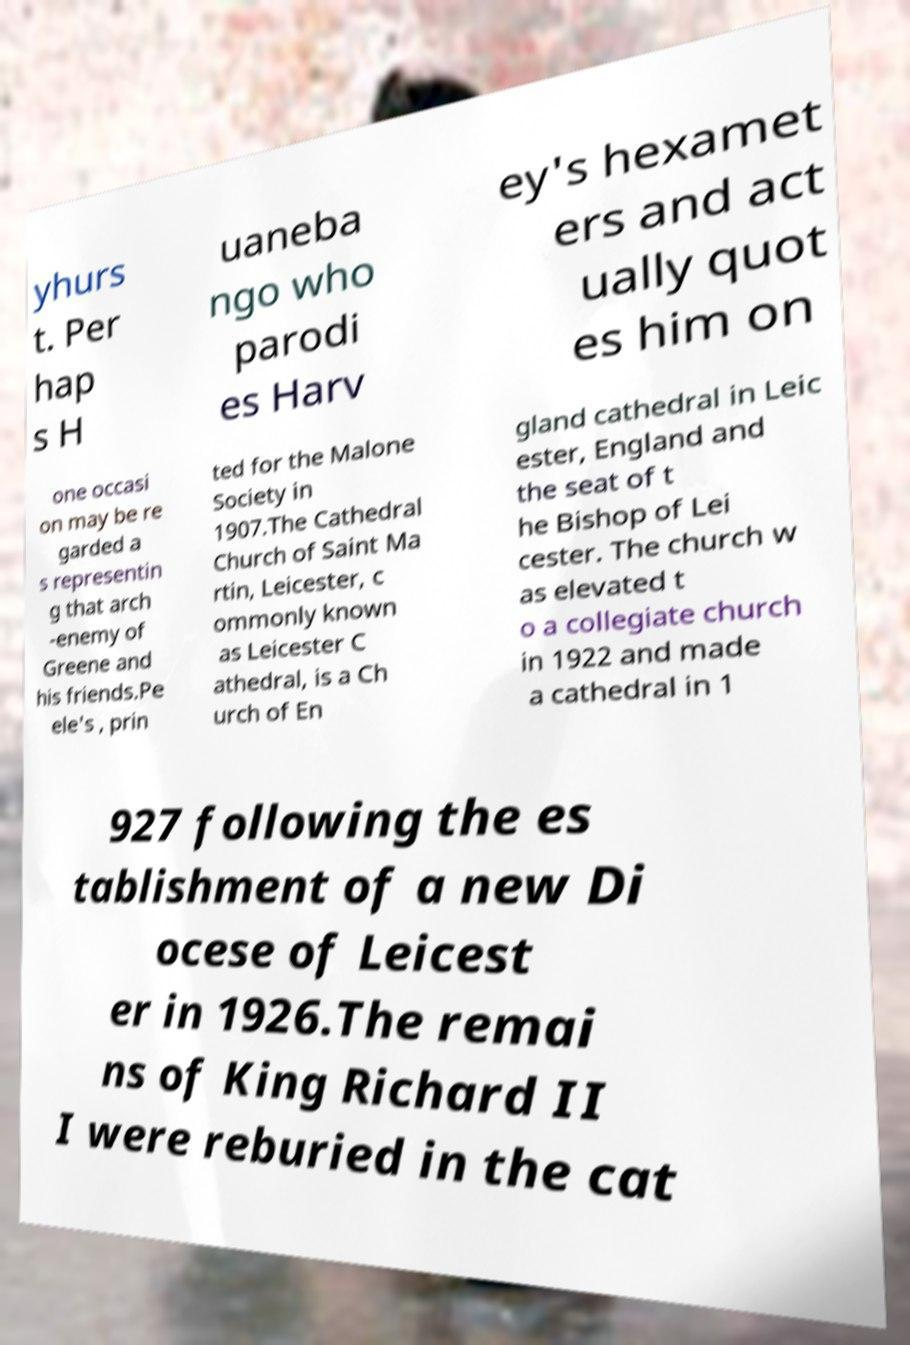I need the written content from this picture converted into text. Can you do that? yhurs t. Per hap s H uaneba ngo who parodi es Harv ey's hexamet ers and act ually quot es him on one occasi on may be re garded a s representin g that arch -enemy of Greene and his friends.Pe ele's , prin ted for the Malone Society in 1907.The Cathedral Church of Saint Ma rtin, Leicester, c ommonly known as Leicester C athedral, is a Ch urch of En gland cathedral in Leic ester, England and the seat of t he Bishop of Lei cester. The church w as elevated t o a collegiate church in 1922 and made a cathedral in 1 927 following the es tablishment of a new Di ocese of Leicest er in 1926.The remai ns of King Richard II I were reburied in the cat 